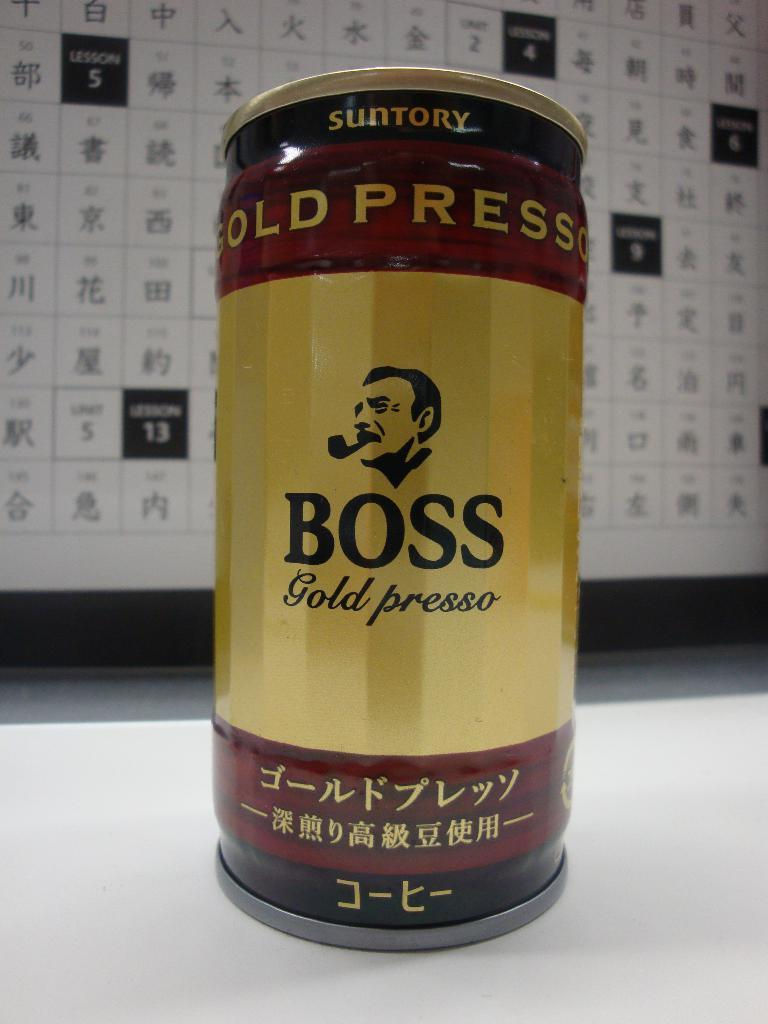<image>
Offer a succinct explanation of the picture presented. A gold can is labelled Boss Gold Presso. 